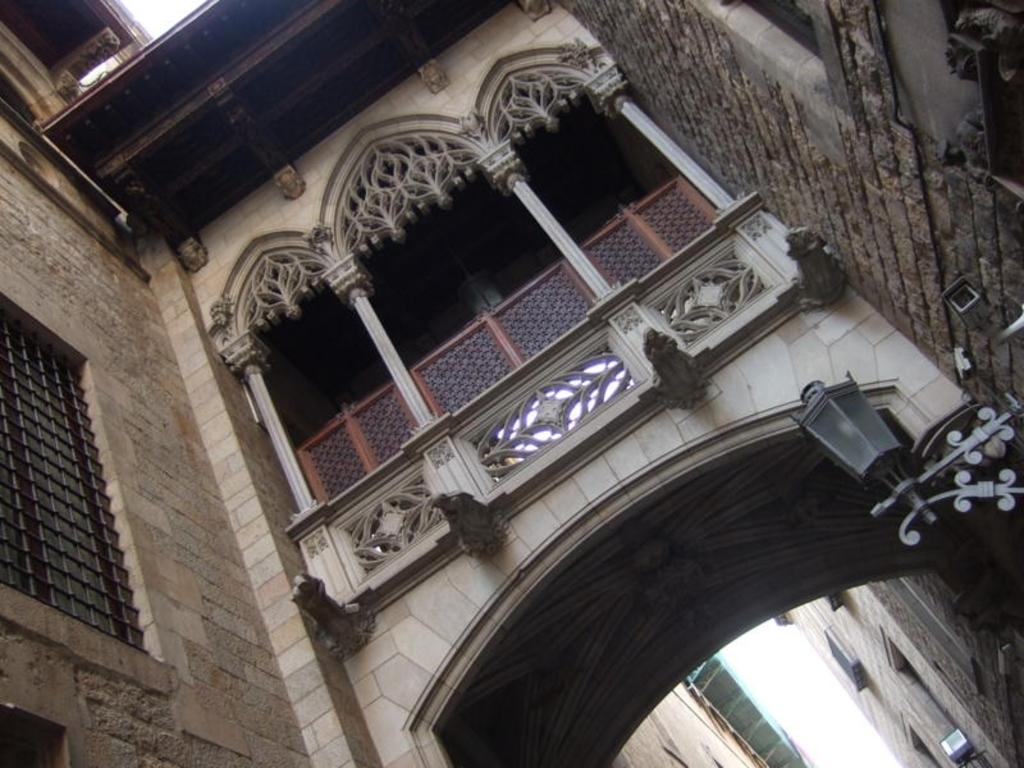What type of structure can be seen in the image? There is an arch in the image. What type of lighting is present in the image? There is a lamp in the image. What type of security device is present in the image? There is a CCTV camera in the image. What type of man-made structures are visible in the image? There are buildings in the image. What other unspecified objects can be seen in the image? There are some unspecified objects in the image. What type of needle can be seen in the image? There is no needle present in the image. What type of behavior can be observed in the image? The image does not depict any behavior; it is a still image of structures and objects. 